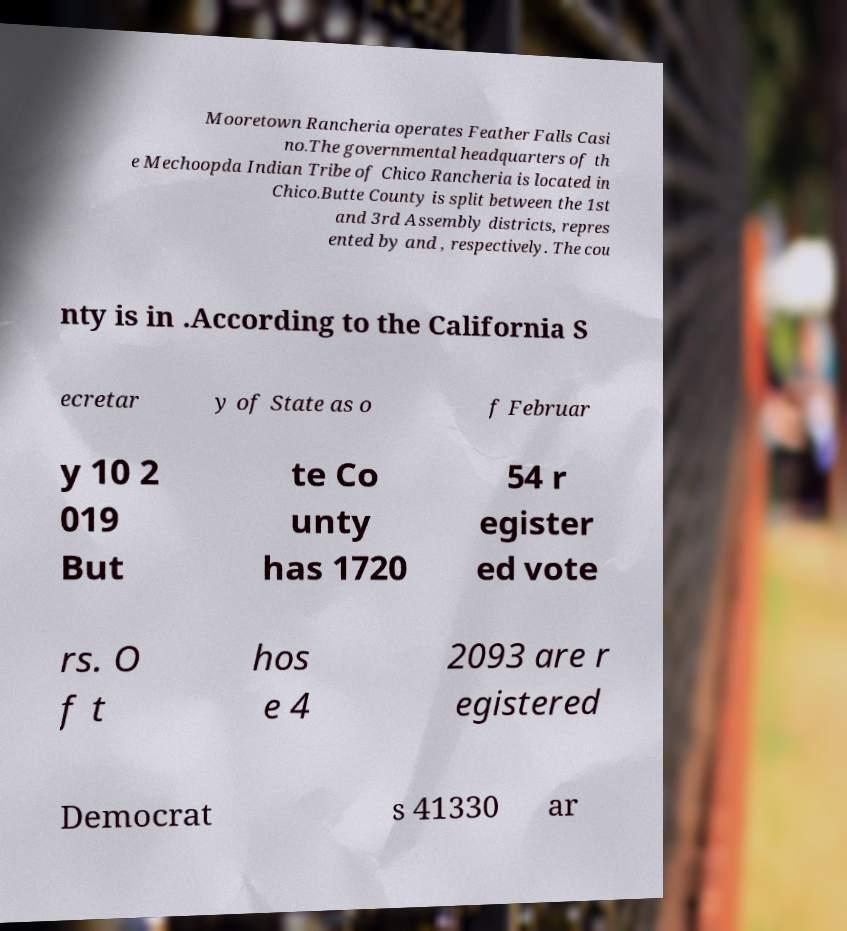There's text embedded in this image that I need extracted. Can you transcribe it verbatim? Mooretown Rancheria operates Feather Falls Casi no.The governmental headquarters of th e Mechoopda Indian Tribe of Chico Rancheria is located in Chico.Butte County is split between the 1st and 3rd Assembly districts, repres ented by and , respectively. The cou nty is in .According to the California S ecretar y of State as o f Februar y 10 2 019 But te Co unty has 1720 54 r egister ed vote rs. O f t hos e 4 2093 are r egistered Democrat s 41330 ar 